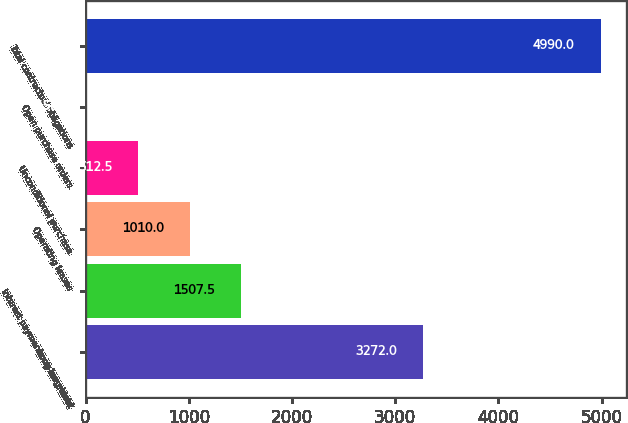Convert chart. <chart><loc_0><loc_0><loc_500><loc_500><bar_chart><fcel>Long-term debt<fcel>Interest payments on long-term<fcel>Operating leases<fcel>Unconditional purchase<fcel>Open purchase orders<fcel>Total contractual obligations<nl><fcel>3272<fcel>1507.5<fcel>1010<fcel>512.5<fcel>15<fcel>4990<nl></chart> 